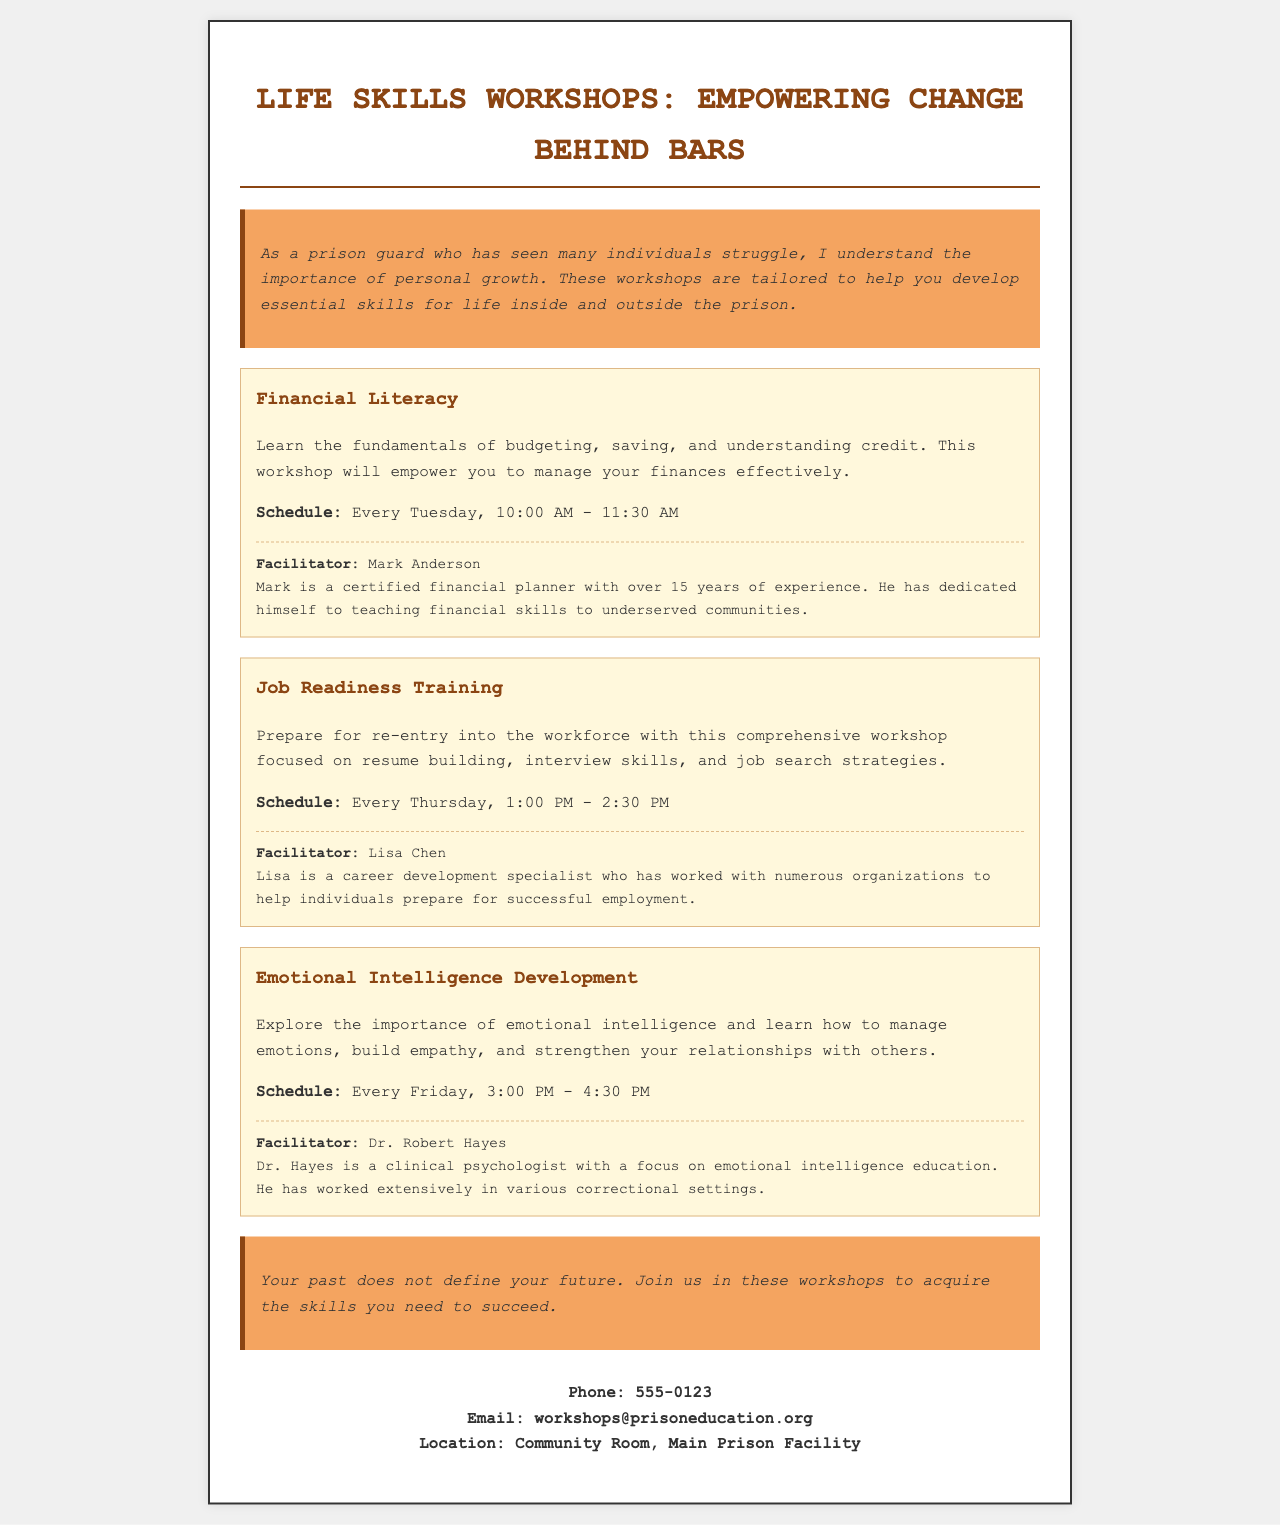What is the title of the brochure? The title of the brochure is found at the top of the document, clearly stated as the main heading.
Answer: Life Skills Workshops: Empowering Change Behind Bars Who is the facilitator for the Financial Literacy workshop? The facilitator for the Financial Literacy workshop is mentioned below the workshop description in a dedicated section.
Answer: Mark Anderson When is the Job Readiness Training scheduled? The schedule for the Job Readiness Training is mentioned below its description in a specific format indicating day and time.
Answer: Every Thursday, 1:00 PM - 2:30 PM What skill area does the Emotional Intelligence Development workshop focus on? This workshop’s focus is presented in the introductory paragraph of the workshop section, explaining its main theme.
Answer: Emotional intelligence How many years of experience does Lisa Chen have? The experience of Lisa Chen is indicated in the facilitator bio associated with the Job Readiness Training workshop.
Answer: Not specified Which room hosts the workshops? The location of the workshops is given at the bottom of the brochure under the contact details section.
Answer: Community Room, Main Prison Facility What importance does the introductory paragraph highlight? The introduction emphasizes the importance of personal growth and skill development for individuals.
Answer: Personal growth What type of training is provided every Friday? The specific training provided on Fridays is mentioned in the heading of that workshop section.
Answer: Emotional Intelligence Development 